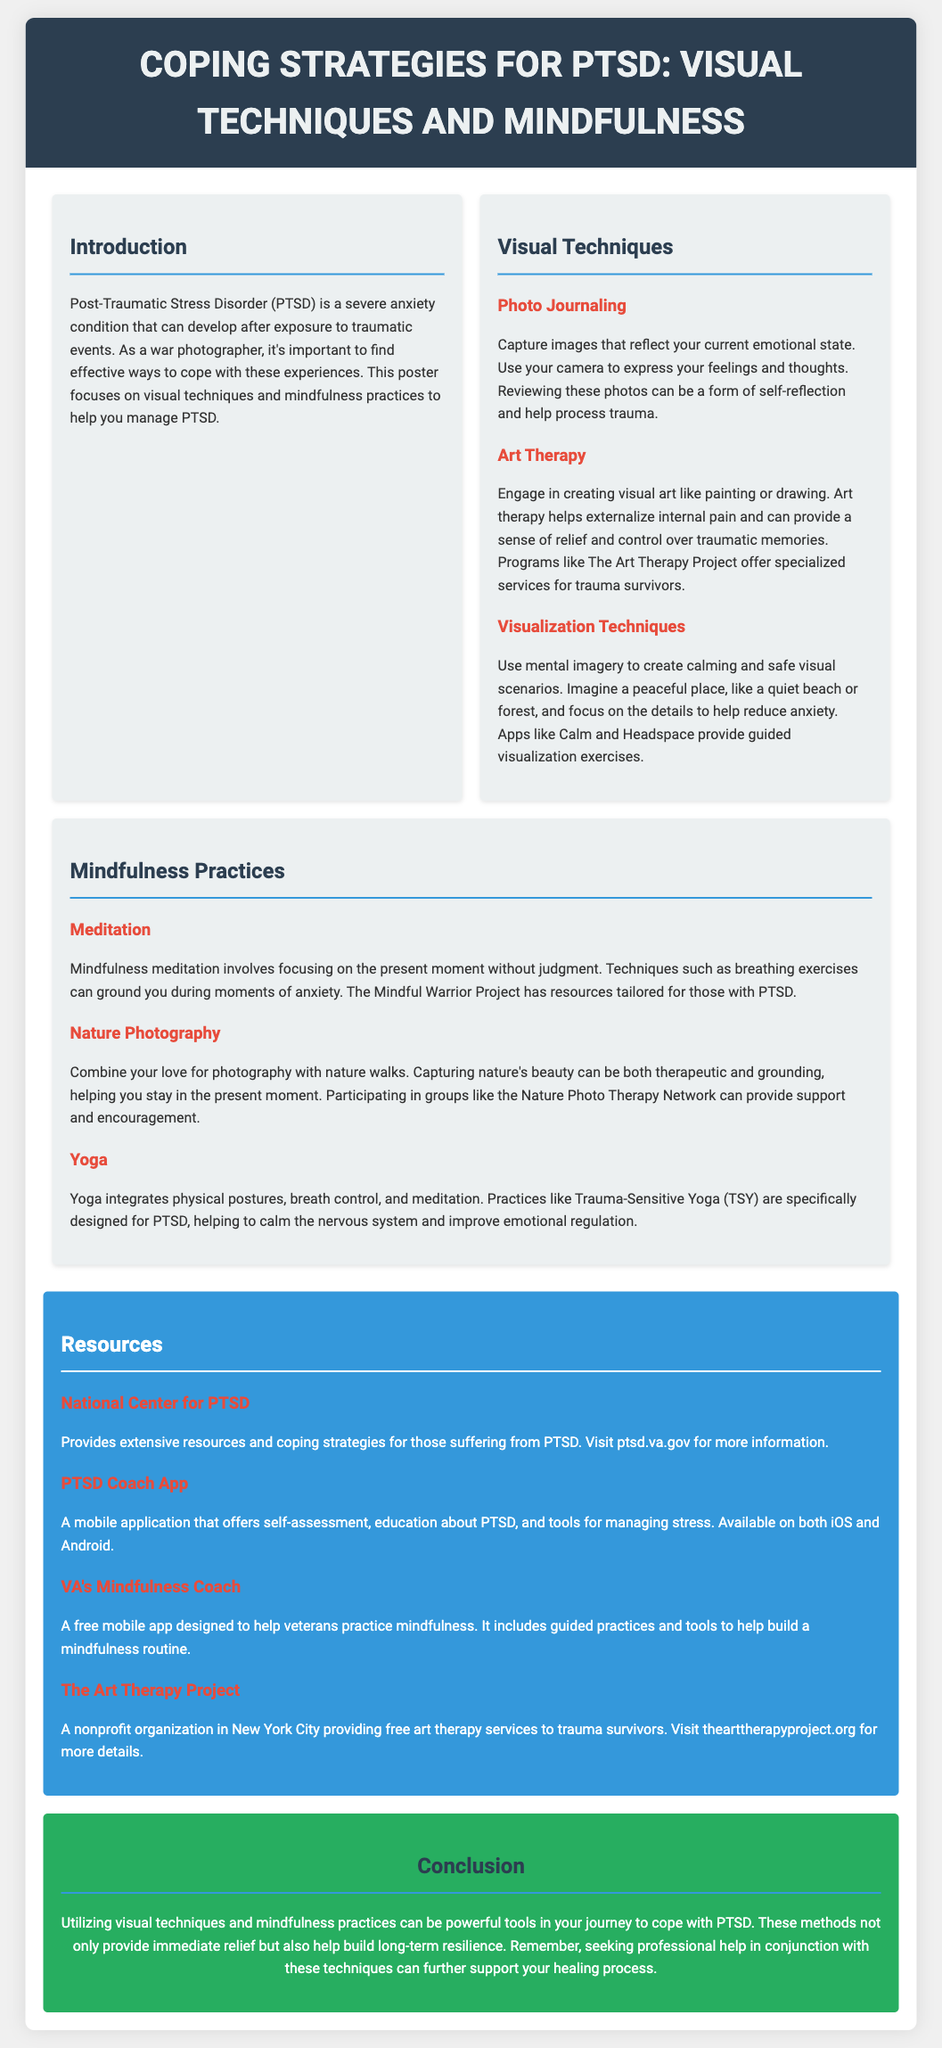What is the main focus of the poster? The poster focuses on effective ways to cope with PTSD through visual techniques and mindfulness practices.
Answer: Visual techniques and mindfulness What is one technique suggested under visual techniques? The poster lists various techniques; one of them is photo journaling.
Answer: Photo journaling What does art therapy help to externalize? Art therapy helps to externalize internal pain and provide relief.
Answer: Internal pain What app is mentioned for guided visualization exercises? The poster recommends Calm and Headspace for guided visualization.
Answer: Calm and Headspace What is a mindfulness practice mentioned in the poster? The poster provides several practices; one is meditation.
Answer: Meditation What organization offers free art therapy services? The Art Therapy Project is mentioned as providing free art therapy services.
Answer: The Art Therapy Project How can nature photography be described in terms of its therapeutic value? Nature photography is described as therapeutic and grounding.
Answer: Therapeutic and grounding What type of yoga is specifically designed for PTSD? Trauma-Sensitive Yoga is specifically designed for PTSD.
Answer: Trauma-Sensitive Yoga What should be sought in conjunction with these techniques for further support? The poster suggests seeking professional help in conjunction with the techniques.
Answer: Professional help 